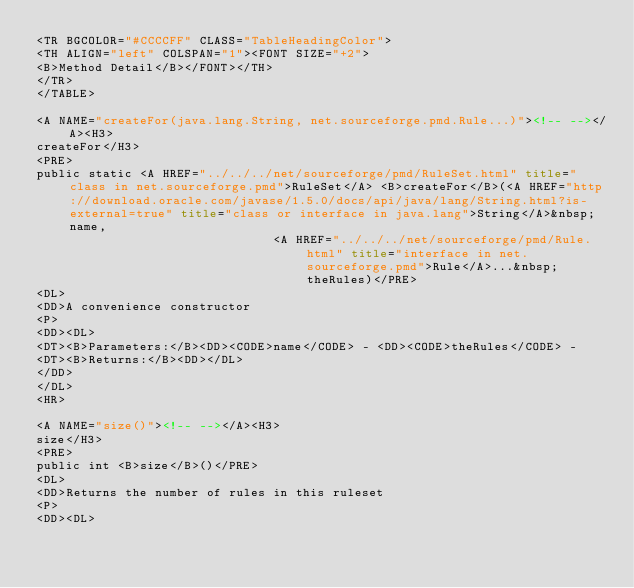Convert code to text. <code><loc_0><loc_0><loc_500><loc_500><_HTML_><TR BGCOLOR="#CCCCFF" CLASS="TableHeadingColor">
<TH ALIGN="left" COLSPAN="1"><FONT SIZE="+2">
<B>Method Detail</B></FONT></TH>
</TR>
</TABLE>

<A NAME="createFor(java.lang.String, net.sourceforge.pmd.Rule...)"><!-- --></A><H3>
createFor</H3>
<PRE>
public static <A HREF="../../../net/sourceforge/pmd/RuleSet.html" title="class in net.sourceforge.pmd">RuleSet</A> <B>createFor</B>(<A HREF="http://download.oracle.com/javase/1.5.0/docs/api/java/lang/String.html?is-external=true" title="class or interface in java.lang">String</A>&nbsp;name,
                                <A HREF="../../../net/sourceforge/pmd/Rule.html" title="interface in net.sourceforge.pmd">Rule</A>...&nbsp;theRules)</PRE>
<DL>
<DD>A convenience constructor
<P>
<DD><DL>
<DT><B>Parameters:</B><DD><CODE>name</CODE> - <DD><CODE>theRules</CODE> - 
<DT><B>Returns:</B><DD></DL>
</DD>
</DL>
<HR>

<A NAME="size()"><!-- --></A><H3>
size</H3>
<PRE>
public int <B>size</B>()</PRE>
<DL>
<DD>Returns the number of rules in this ruleset
<P>
<DD><DL>
</code> 